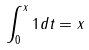<formula> <loc_0><loc_0><loc_500><loc_500>\int _ { 0 } ^ { x } 1 d t = x</formula> 